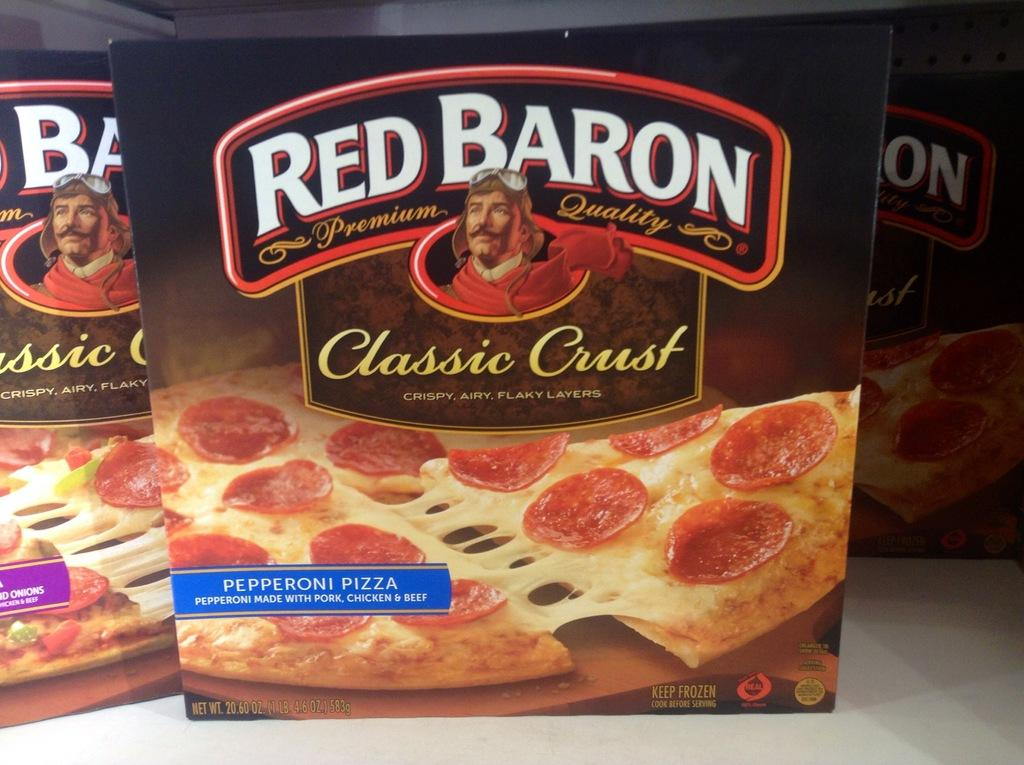How many boxes are on the platform in the image? There are three boxes on the platform in the image. What is on top of one of the boxes? There is a pizza on one of the boxes. What is depicted on one of the boxes? There is a cartoon person depicted on one of the boxes. What arithmetic problem is being solved by the cartoon person on the box? There is no arithmetic problem being solved by the cartoon person on the box; the image only shows a cartoon person depicted on one of the boxes. 